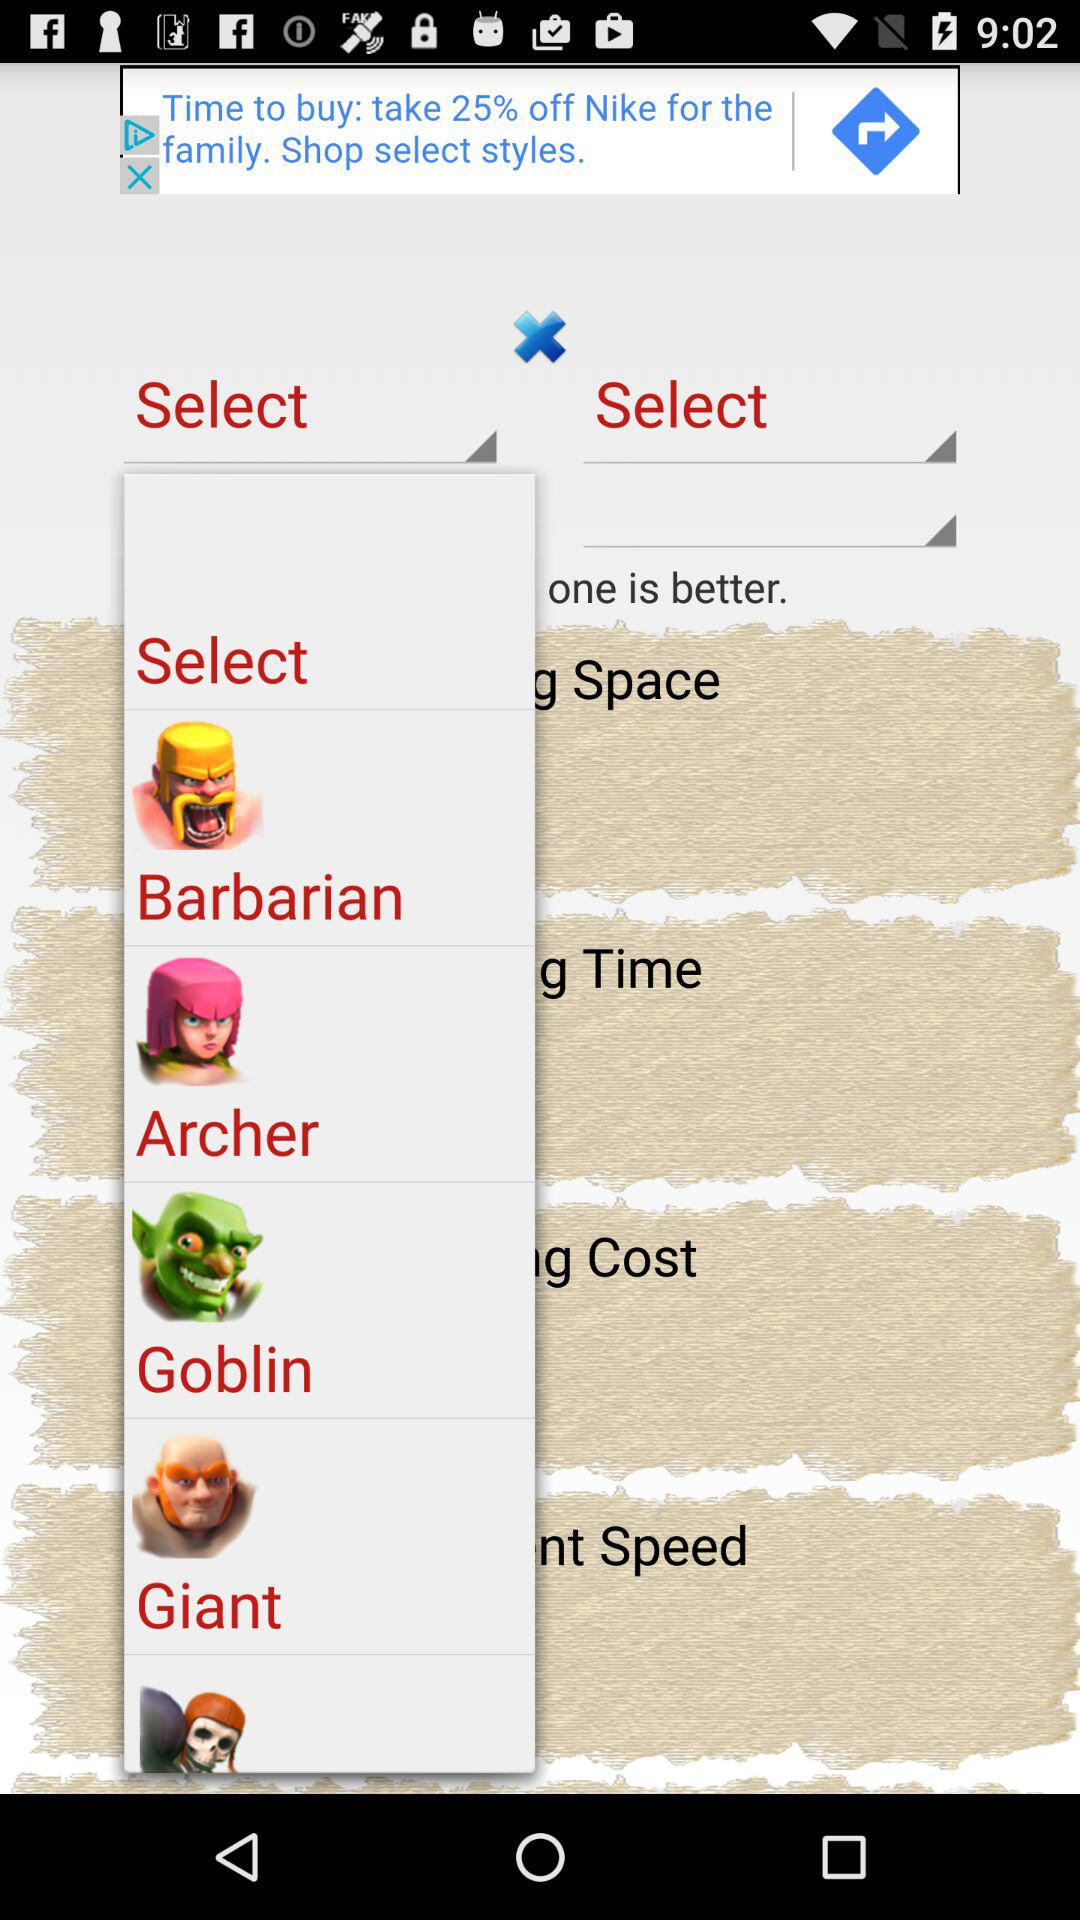Goblin is associated which virtue?
When the provided information is insufficient, respond with <no answer>. <no answer> 